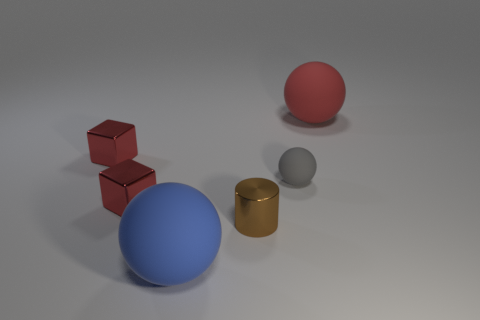Are there fewer brown shiny objects right of the gray object than small spheres that are behind the blue rubber thing?
Give a very brief answer. Yes. Does the big red object have the same material as the tiny brown object?
Provide a short and direct response. No. What is the size of the object that is behind the small gray rubber sphere and right of the big blue matte ball?
Offer a very short reply. Large. What shape is the gray object that is the same size as the brown thing?
Give a very brief answer. Sphere. What is the material of the big sphere behind the big matte thing in front of the large rubber object that is right of the blue thing?
Your response must be concise. Rubber. Does the big rubber object in front of the small gray ball have the same shape as the large object that is to the right of the tiny shiny cylinder?
Provide a short and direct response. Yes. How many other objects are the same material as the tiny brown thing?
Provide a short and direct response. 2. Is the big thing behind the tiny brown metallic thing made of the same material as the large ball that is in front of the tiny rubber thing?
Give a very brief answer. Yes. There is a red thing that is the same material as the gray object; what shape is it?
Make the answer very short. Sphere. What number of tiny yellow cubes are there?
Offer a terse response. 0. 